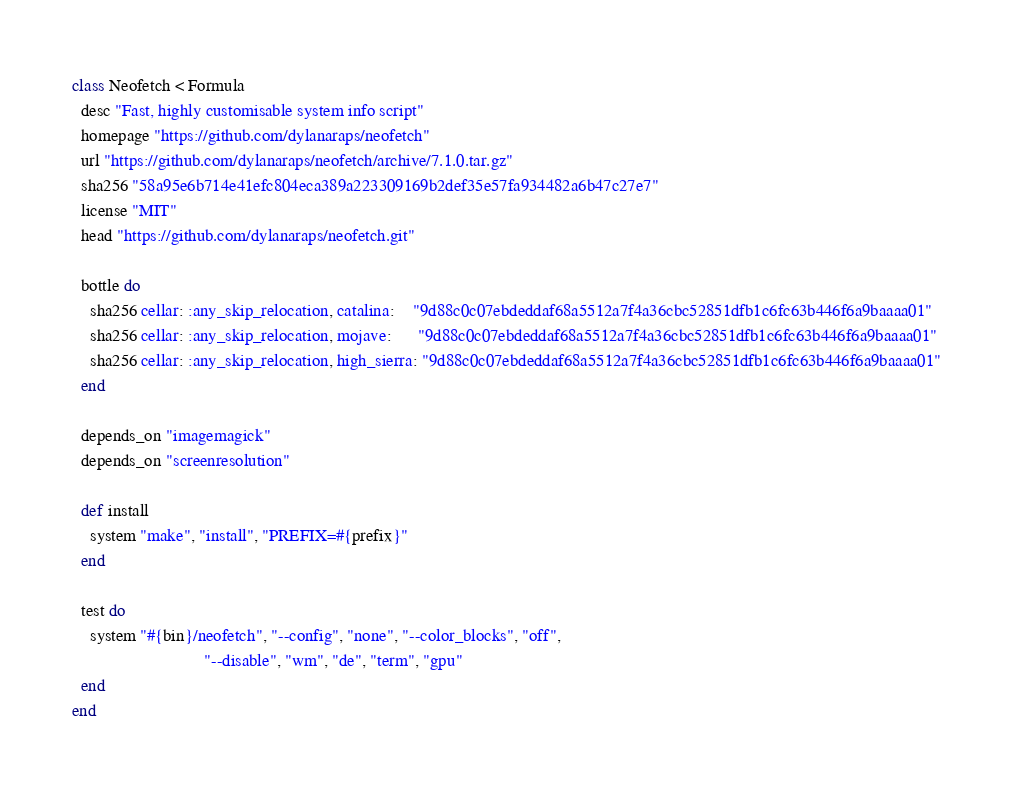Convert code to text. <code><loc_0><loc_0><loc_500><loc_500><_Ruby_>class Neofetch < Formula
  desc "Fast, highly customisable system info script"
  homepage "https://github.com/dylanaraps/neofetch"
  url "https://github.com/dylanaraps/neofetch/archive/7.1.0.tar.gz"
  sha256 "58a95e6b714e41efc804eca389a223309169b2def35e57fa934482a6b47c27e7"
  license "MIT"
  head "https://github.com/dylanaraps/neofetch.git"

  bottle do
    sha256 cellar: :any_skip_relocation, catalina:    "9d88c0c07ebdeddaf68a5512a7f4a36cbc52851dfb1c6fc63b446f6a9baaaa01"
    sha256 cellar: :any_skip_relocation, mojave:      "9d88c0c07ebdeddaf68a5512a7f4a36cbc52851dfb1c6fc63b446f6a9baaaa01"
    sha256 cellar: :any_skip_relocation, high_sierra: "9d88c0c07ebdeddaf68a5512a7f4a36cbc52851dfb1c6fc63b446f6a9baaaa01"
  end

  depends_on "imagemagick"
  depends_on "screenresolution"

  def install
    system "make", "install", "PREFIX=#{prefix}"
  end

  test do
    system "#{bin}/neofetch", "--config", "none", "--color_blocks", "off",
                              "--disable", "wm", "de", "term", "gpu"
  end
end
</code> 